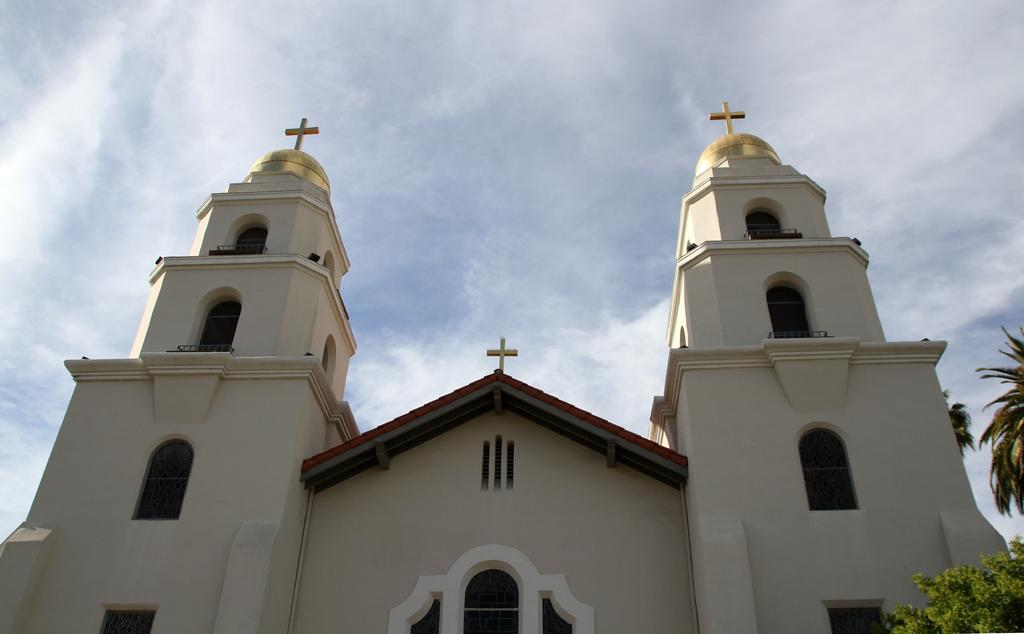What type of structure is visible in the image? There is a building in the image. What natural element is present in the image? There is a tree in the image. What religious symbols can be seen in the image? Cross symbols are present in the image. What architectural feature is visible on the building? There are windows in the image. What can be seen in the background of the image? The sky is visible in the background of the image. Can you describe the texture of the wool in the image? There is no wool present in the image. How many times does the person kick the ball in the image? There is no person or ball present in the image. 